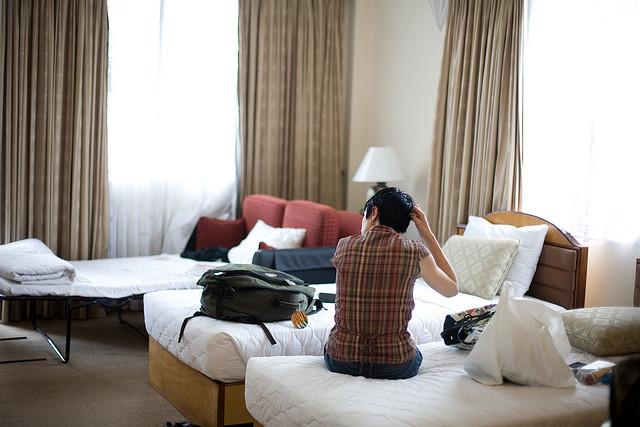Is the girl combing her hair?
Write a very short answer. Yes. Is this a hotel?
Answer briefly. Yes. How many beds are here?
Concise answer only. 3. 